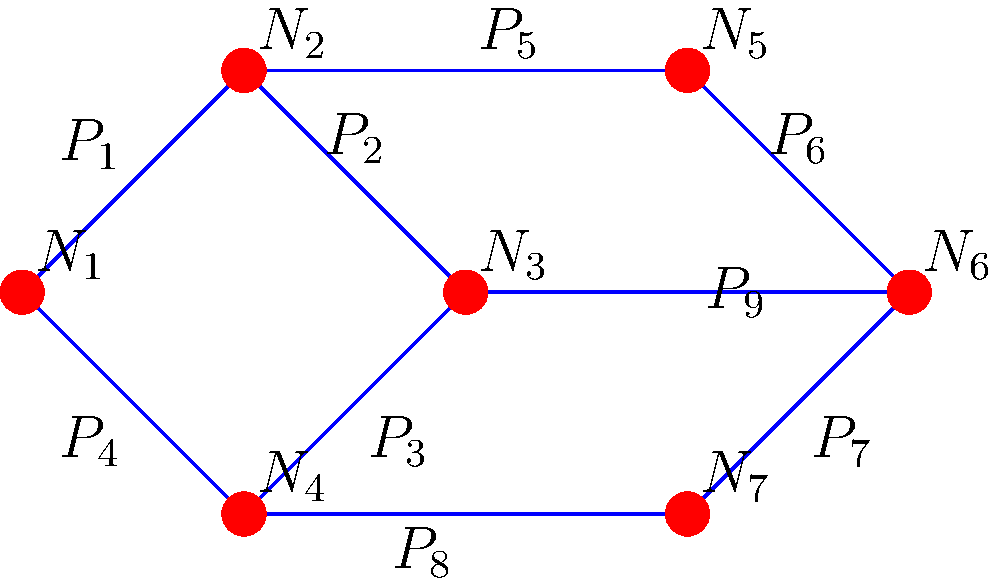As the CEO of the dominant HR platform, you're expanding your knowledge base to better understand the challenges faced by various industries. In the context of civil engineering, consider the water distribution network layout for a small town shown above. If pipe $P_5$ needs to be shut down for maintenance, which nodes will be directly affected, and how many alternative paths exist to maintain water supply to these affected nodes? To answer this question, we need to analyze the network layout step-by-step:

1. Identify the nodes connected by pipe $P_5$:
   - $P_5$ connects nodes $N_2$ and $N_5$

2. Determine the directly affected nodes:
   - Node $N_2$ is not directly affected as it has alternative connections ($P_1$, $P_2$, $P_3$)
   - Node $N_5$ is directly affected as $P_5$ is its only connection to the main network

3. Count alternative paths to maintain water supply to $N_5$:
   - Path 1: $N_1 \rightarrow N_2 \rightarrow N_3 \rightarrow N_4 \rightarrow N_7 \rightarrow N_6 \rightarrow N_5$
   - Path 2: $N_1 \rightarrow N_2 \rightarrow N_6 \rightarrow N_5$

4. Summarize the findings:
   - Only one node ($N_5$) is directly affected
   - There are two alternative paths to maintain water supply to $N_5$

This analysis demonstrates the importance of redundancy in network design, ensuring continuous service even during maintenance operations.
Answer: 1 node affected; 2 alternative paths 